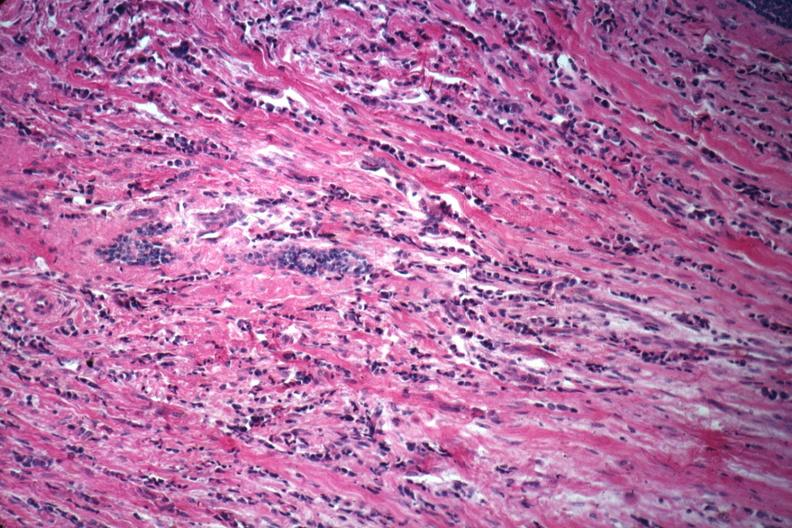what is present?
Answer the question using a single word or phrase. Breast 